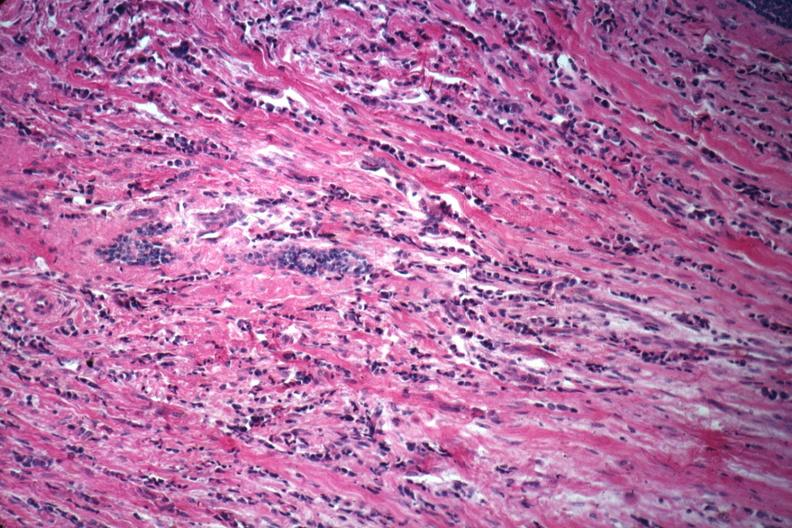what is present?
Answer the question using a single word or phrase. Breast 